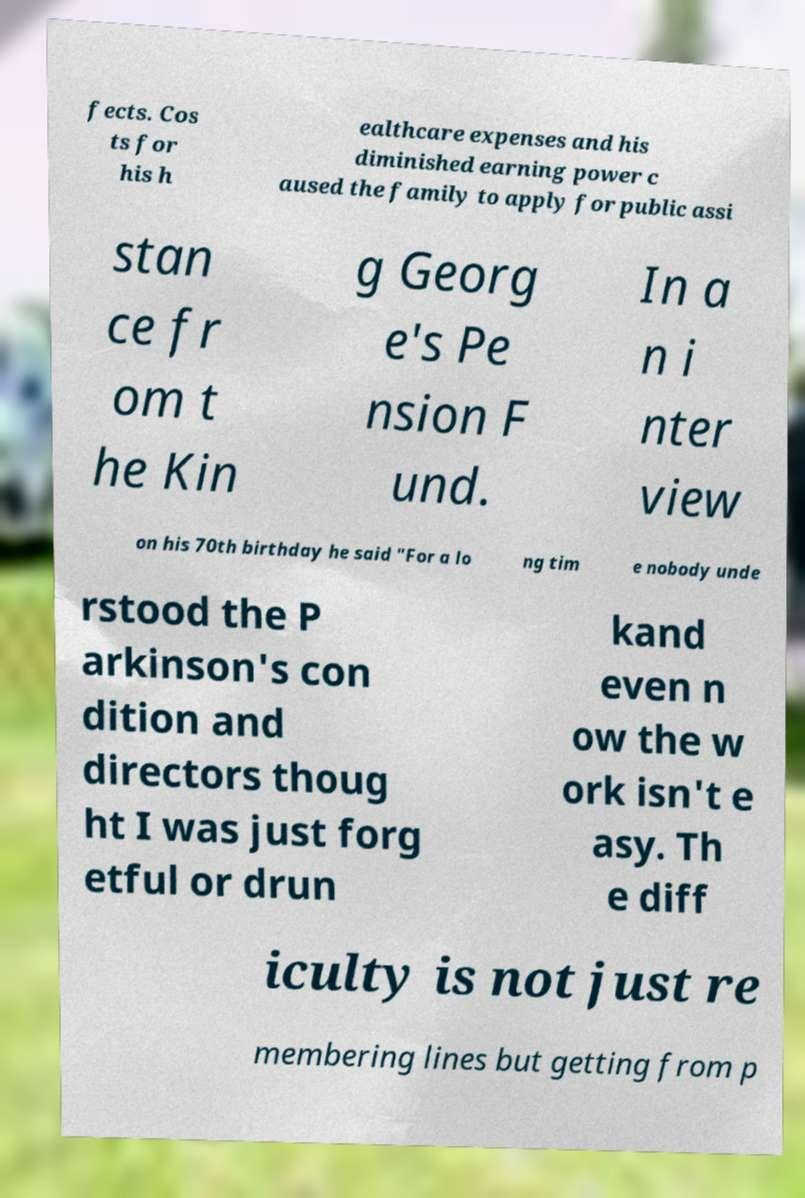Could you extract and type out the text from this image? fects. Cos ts for his h ealthcare expenses and his diminished earning power c aused the family to apply for public assi stan ce fr om t he Kin g Georg e's Pe nsion F und. In a n i nter view on his 70th birthday he said "For a lo ng tim e nobody unde rstood the P arkinson's con dition and directors thoug ht I was just forg etful or drun kand even n ow the w ork isn't e asy. Th e diff iculty is not just re membering lines but getting from p 